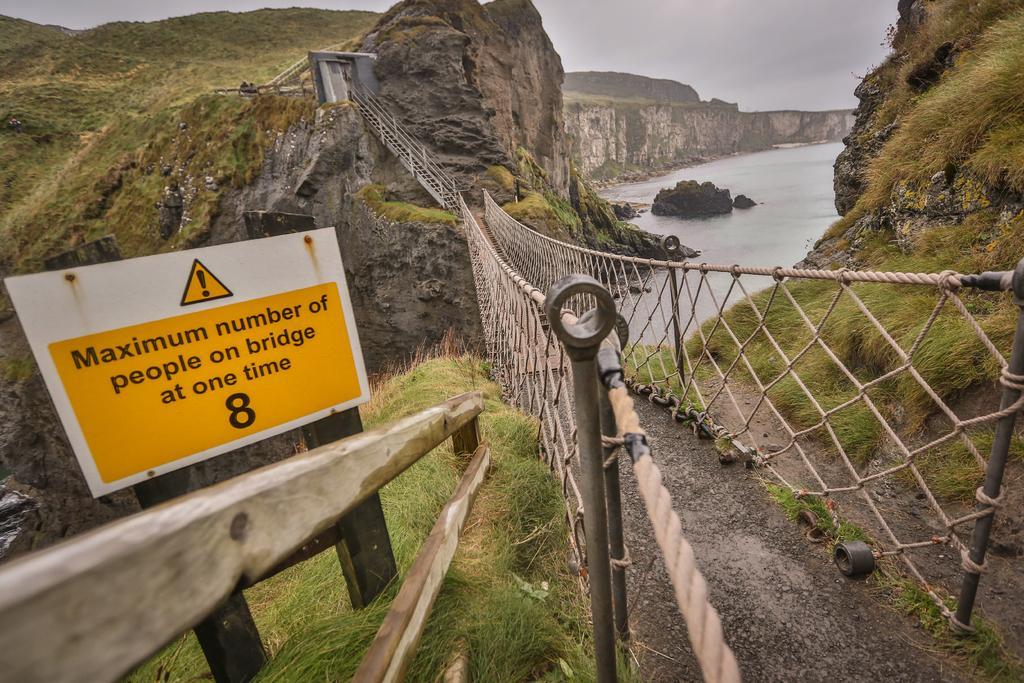In one or two sentences, can you explain what this image depicts? In this image, we can see the bridge and the fence. We can also see some hills and some grass. We can see some water with a few objects and a board with some text. We can see the sky. 